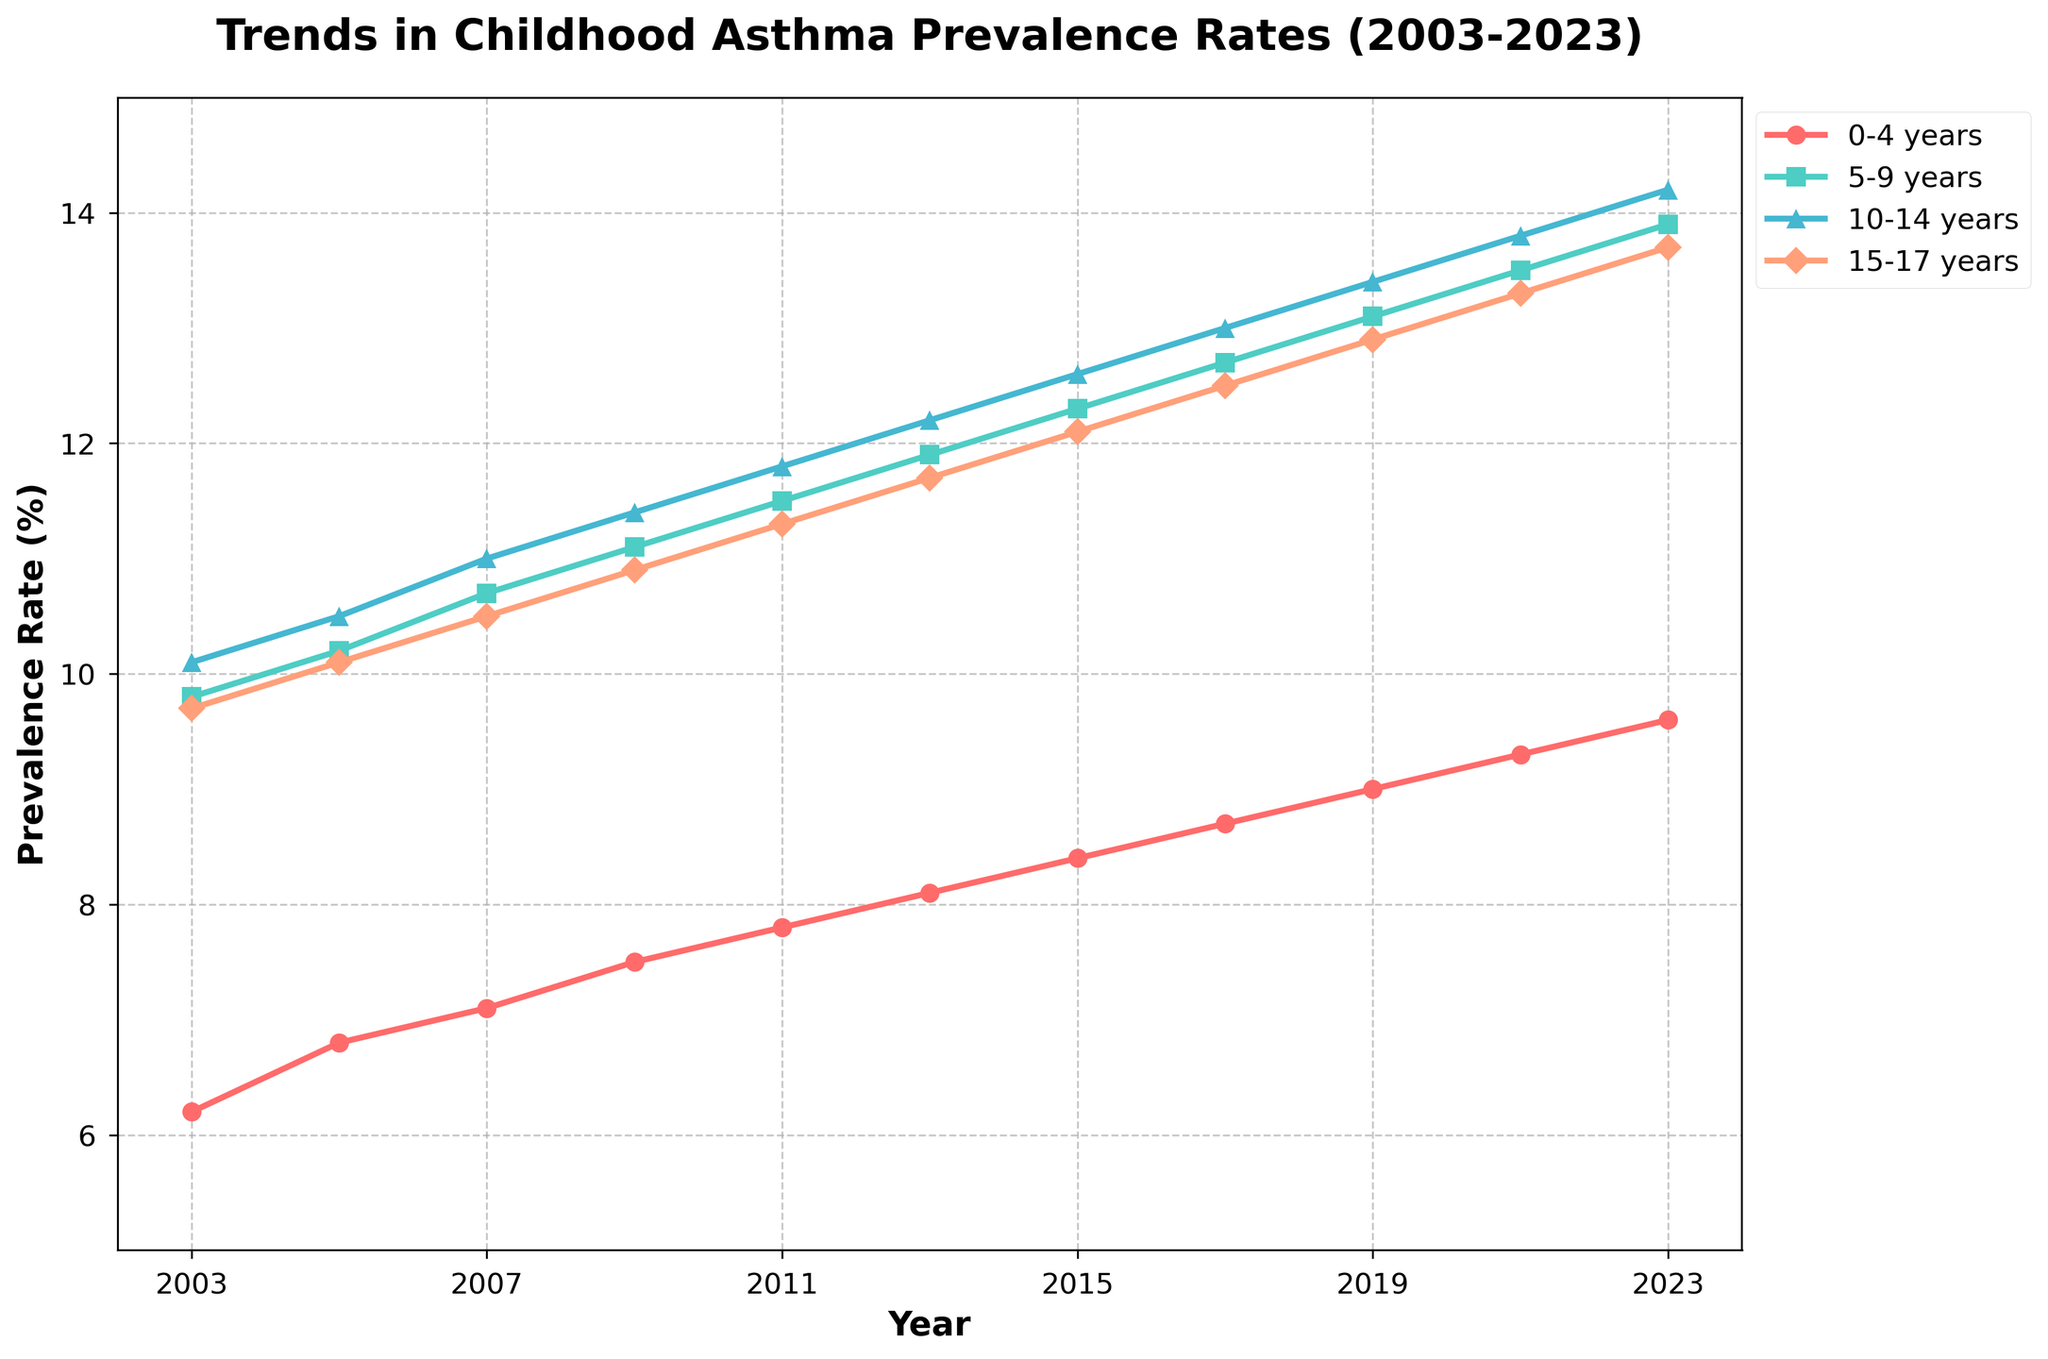What is the prevalence rate of asthma for the 0-4 years age group in 2023? To find the prevalence rate of asthma for the 0-4 years age group in 2023, look at the plotted line for the 0-4 years group. The endpoint corresponding to the year 2023 shows 9.6%.
Answer: 9.6% Which age group saw the largest increase in asthma prevalence from 2003 to 2023? Compare the starting and ending points for each age group from 2003 to 2023. The 0-4 years age group increased from 6.2% to 9.6%, which is an increase of 3.4%. The 5-9 years group increased by 4.1%, the 10-14 years group by 4.1%, and the 15-17 years group by 4.0%. Therefore, the 5-9 and 10-14 years age groups saw the largest increase.
Answer: 5-9 years and 10-14 years Which age group had the highest asthma prevalence in 2009? Identify the data points for 2009 across all age groups and determine the maximum value. For 2009, the rates are 7.5% (0-4 years), 11.1% (5-9 years), 11.4% (10-14 years), and 10.9% (15-17 years). The highest value is for the 10-14 years age group with 11.4%.
Answer: 10-14 years How does the trend of asthma prevalence in the 10-14 years age group compare to the 15-17 years age group from 2003 to 2023? Evaluate the plotted lines for the 10-14 and 15-17 years age groups. Both age groups show a generally increasing trend, but the 10-14 years group consistently has a higher prevalence rate over time. Both groups increase by approximately 4 percentage points from 2003 to 2023.
Answer: Both increase, but 10-14 years group is consistently higher What is the average asthma prevalence rate across all age groups in 2023? Calculate the mean of the asthma prevalence rates for all age groups in 2023. The values for 0-4 years, 5-9 years, 10-14 years, and 15-17 years are 9.6%, 13.9%, 14.2%, and 13.7%, respectively. The average is (9.6 + 13.9 + 14.2 + 13.7) / 4 = 12.85%.
Answer: 12.85% What is the difference in asthma prevalence between the 5-9 years and 0-4 years age groups in 2017? Look at the plot for the year 2017, find the asthma prevalence rates for 5-9 years (12.7%) and 0-4 years (8.7%). The difference is 12.7% - 8.7% = 4.0%.
Answer: 4.0% Which color represents the 0-4 years age group, and how does its trend look overall? Identify the color representing the 0-4 years age group by looking at the legend in the plot, which indicates the 0-4 years group by a red line. The overall trend of this red line shows a steady increase in asthma prevalence from 2003 to 2023.
Answer: Red, increasing trend Is there any age group that showed a decreasing trend in asthma prevalence at any time during the period from 2003 to 2023? Examine the plotted lines for any downward slopes at any period. All lines show a continuous upward trend, indicating no age group exhibited a decrease in asthma prevalence during this period.
Answer: No What is the yearly increase in asthma prevalence rate for the 10-14 years age group on average between 2003 and 2023? To find the average yearly increase, take the difference between the prevalence rates in 2023 and 2003 for the 10-14 years group (14.2% - 10.1% = 4.1%) and divide by the number of years (2023 - 2003 = 20). The average yearly increase is 4.1% / 20 = 0.205%.
Answer: 0.205% 